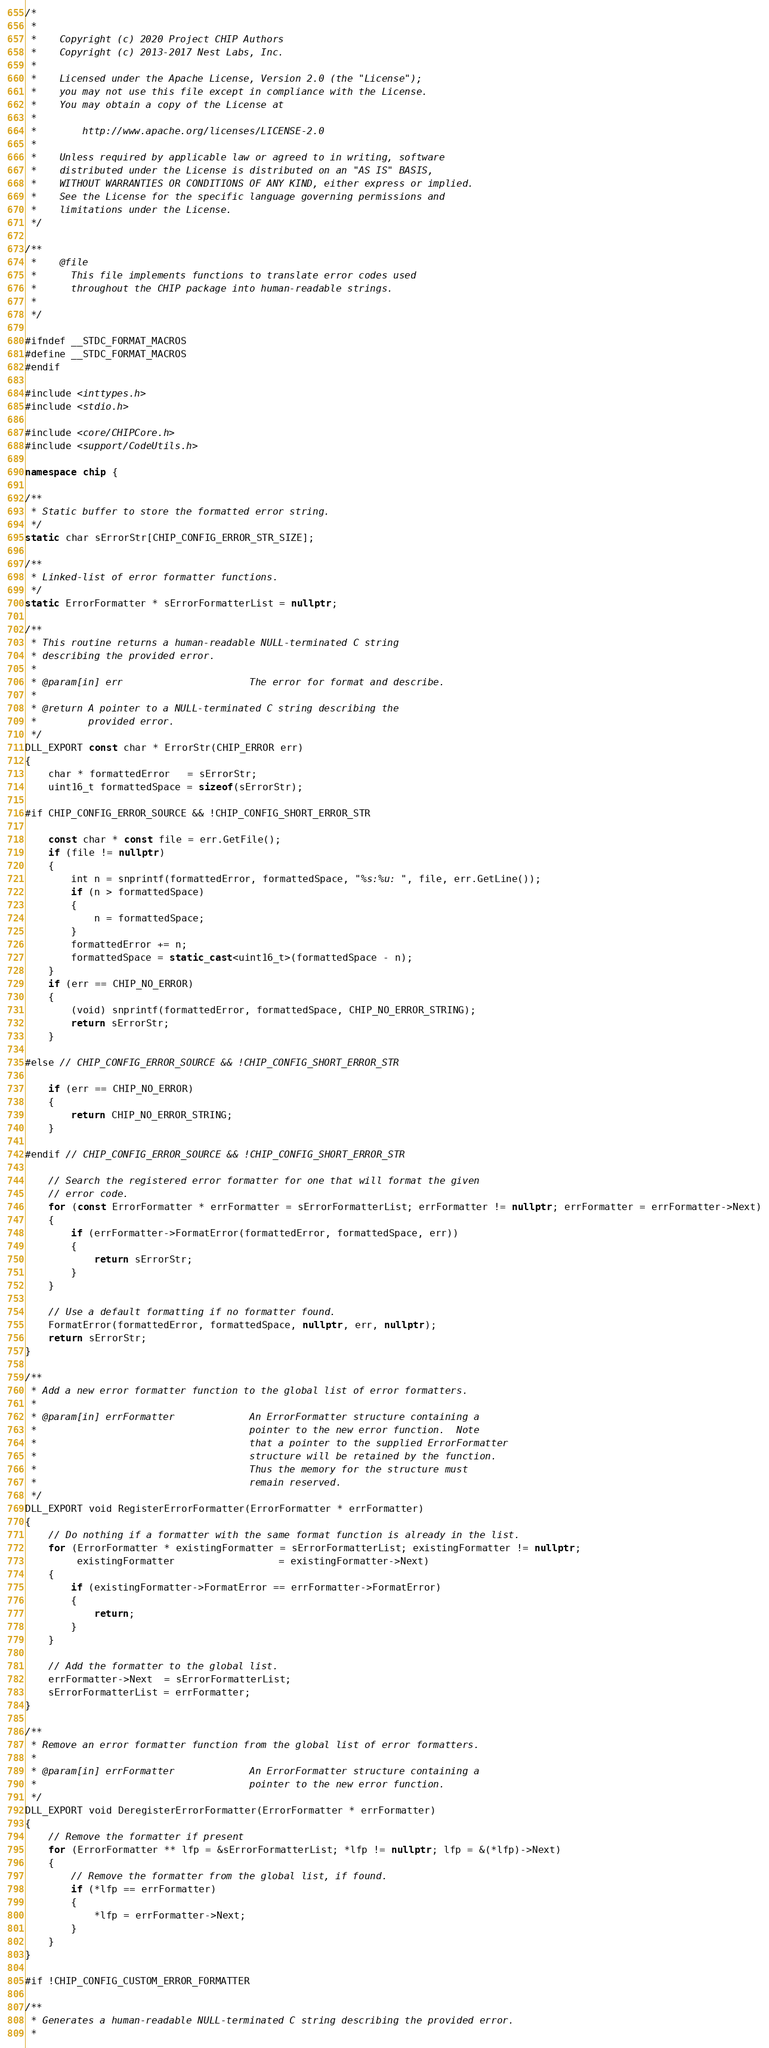<code> <loc_0><loc_0><loc_500><loc_500><_C++_>/*
 *
 *    Copyright (c) 2020 Project CHIP Authors
 *    Copyright (c) 2013-2017 Nest Labs, Inc.
 *
 *    Licensed under the Apache License, Version 2.0 (the "License");
 *    you may not use this file except in compliance with the License.
 *    You may obtain a copy of the License at
 *
 *        http://www.apache.org/licenses/LICENSE-2.0
 *
 *    Unless required by applicable law or agreed to in writing, software
 *    distributed under the License is distributed on an "AS IS" BASIS,
 *    WITHOUT WARRANTIES OR CONDITIONS OF ANY KIND, either express or implied.
 *    See the License for the specific language governing permissions and
 *    limitations under the License.
 */

/**
 *    @file
 *      This file implements functions to translate error codes used
 *      throughout the CHIP package into human-readable strings.
 *
 */

#ifndef __STDC_FORMAT_MACROS
#define __STDC_FORMAT_MACROS
#endif

#include <inttypes.h>
#include <stdio.h>

#include <core/CHIPCore.h>
#include <support/CodeUtils.h>

namespace chip {

/**
 * Static buffer to store the formatted error string.
 */
static char sErrorStr[CHIP_CONFIG_ERROR_STR_SIZE];

/**
 * Linked-list of error formatter functions.
 */
static ErrorFormatter * sErrorFormatterList = nullptr;

/**
 * This routine returns a human-readable NULL-terminated C string
 * describing the provided error.
 *
 * @param[in] err                      The error for format and describe.
 *
 * @return A pointer to a NULL-terminated C string describing the
 *         provided error.
 */
DLL_EXPORT const char * ErrorStr(CHIP_ERROR err)
{
    char * formattedError   = sErrorStr;
    uint16_t formattedSpace = sizeof(sErrorStr);

#if CHIP_CONFIG_ERROR_SOURCE && !CHIP_CONFIG_SHORT_ERROR_STR

    const char * const file = err.GetFile();
    if (file != nullptr)
    {
        int n = snprintf(formattedError, formattedSpace, "%s:%u: ", file, err.GetLine());
        if (n > formattedSpace)
        {
            n = formattedSpace;
        }
        formattedError += n;
        formattedSpace = static_cast<uint16_t>(formattedSpace - n);
    }
    if (err == CHIP_NO_ERROR)
    {
        (void) snprintf(formattedError, formattedSpace, CHIP_NO_ERROR_STRING);
        return sErrorStr;
    }

#else // CHIP_CONFIG_ERROR_SOURCE && !CHIP_CONFIG_SHORT_ERROR_STR

    if (err == CHIP_NO_ERROR)
    {
        return CHIP_NO_ERROR_STRING;
    }

#endif // CHIP_CONFIG_ERROR_SOURCE && !CHIP_CONFIG_SHORT_ERROR_STR

    // Search the registered error formatter for one that will format the given
    // error code.
    for (const ErrorFormatter * errFormatter = sErrorFormatterList; errFormatter != nullptr; errFormatter = errFormatter->Next)
    {
        if (errFormatter->FormatError(formattedError, formattedSpace, err))
        {
            return sErrorStr;
        }
    }

    // Use a default formatting if no formatter found.
    FormatError(formattedError, formattedSpace, nullptr, err, nullptr);
    return sErrorStr;
}

/**
 * Add a new error formatter function to the global list of error formatters.
 *
 * @param[in] errFormatter             An ErrorFormatter structure containing a
 *                                     pointer to the new error function.  Note
 *                                     that a pointer to the supplied ErrorFormatter
 *                                     structure will be retained by the function.
 *                                     Thus the memory for the structure must
 *                                     remain reserved.
 */
DLL_EXPORT void RegisterErrorFormatter(ErrorFormatter * errFormatter)
{
    // Do nothing if a formatter with the same format function is already in the list.
    for (ErrorFormatter * existingFormatter = sErrorFormatterList; existingFormatter != nullptr;
         existingFormatter                  = existingFormatter->Next)
    {
        if (existingFormatter->FormatError == errFormatter->FormatError)
        {
            return;
        }
    }

    // Add the formatter to the global list.
    errFormatter->Next  = sErrorFormatterList;
    sErrorFormatterList = errFormatter;
}

/**
 * Remove an error formatter function from the global list of error formatters.
 *
 * @param[in] errFormatter             An ErrorFormatter structure containing a
 *                                     pointer to the new error function.
 */
DLL_EXPORT void DeregisterErrorFormatter(ErrorFormatter * errFormatter)
{
    // Remove the formatter if present
    for (ErrorFormatter ** lfp = &sErrorFormatterList; *lfp != nullptr; lfp = &(*lfp)->Next)
    {
        // Remove the formatter from the global list, if found.
        if (*lfp == errFormatter)
        {
            *lfp = errFormatter->Next;
        }
    }
}

#if !CHIP_CONFIG_CUSTOM_ERROR_FORMATTER

/**
 * Generates a human-readable NULL-terminated C string describing the provided error.
 *</code> 